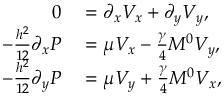<formula> <loc_0><loc_0><loc_500><loc_500>\begin{array} { r l } { 0 } & = \partial _ { x } V _ { x } + \partial _ { y } V _ { y } , } \\ { - \frac { h ^ { 2 } } { 1 2 } \partial _ { x } P } & = \mu V _ { x } - \frac { \gamma } { 4 } M ^ { 0 } V _ { y } , } \\ { - \frac { h ^ { 2 } } { 1 2 } \partial _ { y } P } & = \mu V _ { y } + \frac { \gamma } { 4 } M ^ { 0 } V _ { x } , } \end{array}</formula> 